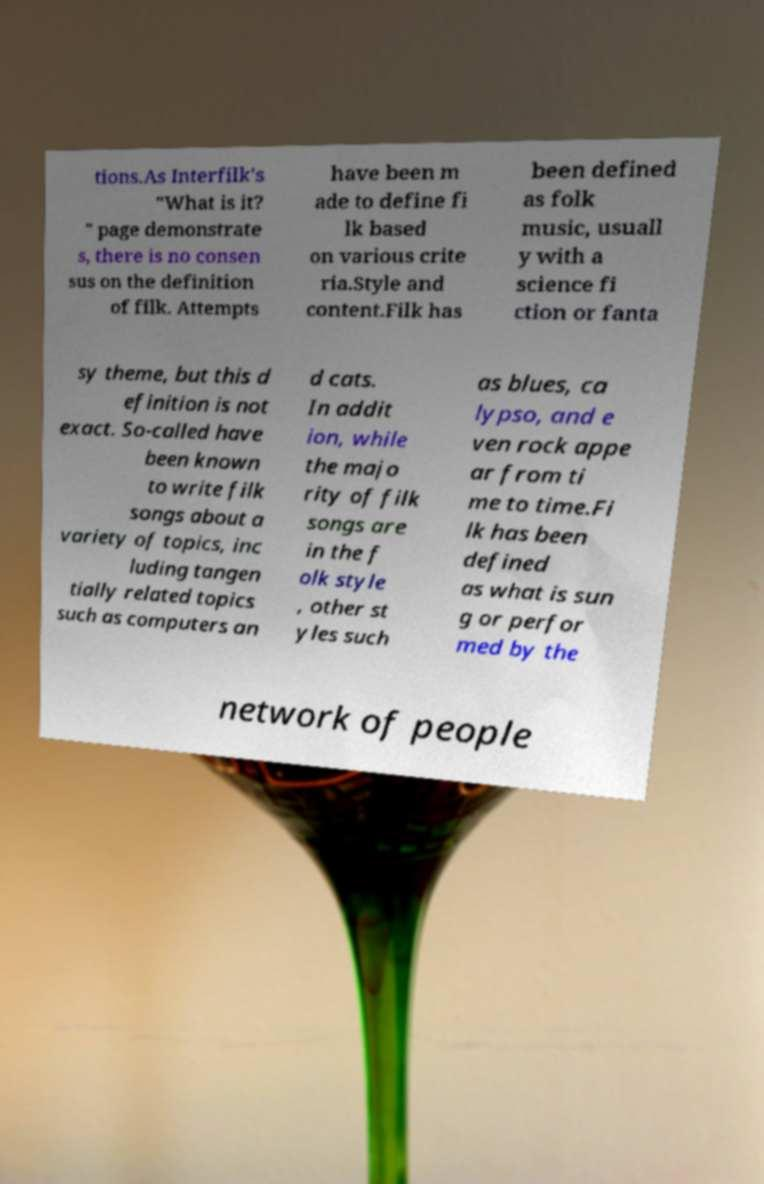Please identify and transcribe the text found in this image. tions.As Interfilk's "What is it? " page demonstrate s, there is no consen sus on the definition of filk. Attempts have been m ade to define fi lk based on various crite ria.Style and content.Filk has been defined as folk music, usuall y with a science fi ction or fanta sy theme, but this d efinition is not exact. So-called have been known to write filk songs about a variety of topics, inc luding tangen tially related topics such as computers an d cats. In addit ion, while the majo rity of filk songs are in the f olk style , other st yles such as blues, ca lypso, and e ven rock appe ar from ti me to time.Fi lk has been defined as what is sun g or perfor med by the network of people 